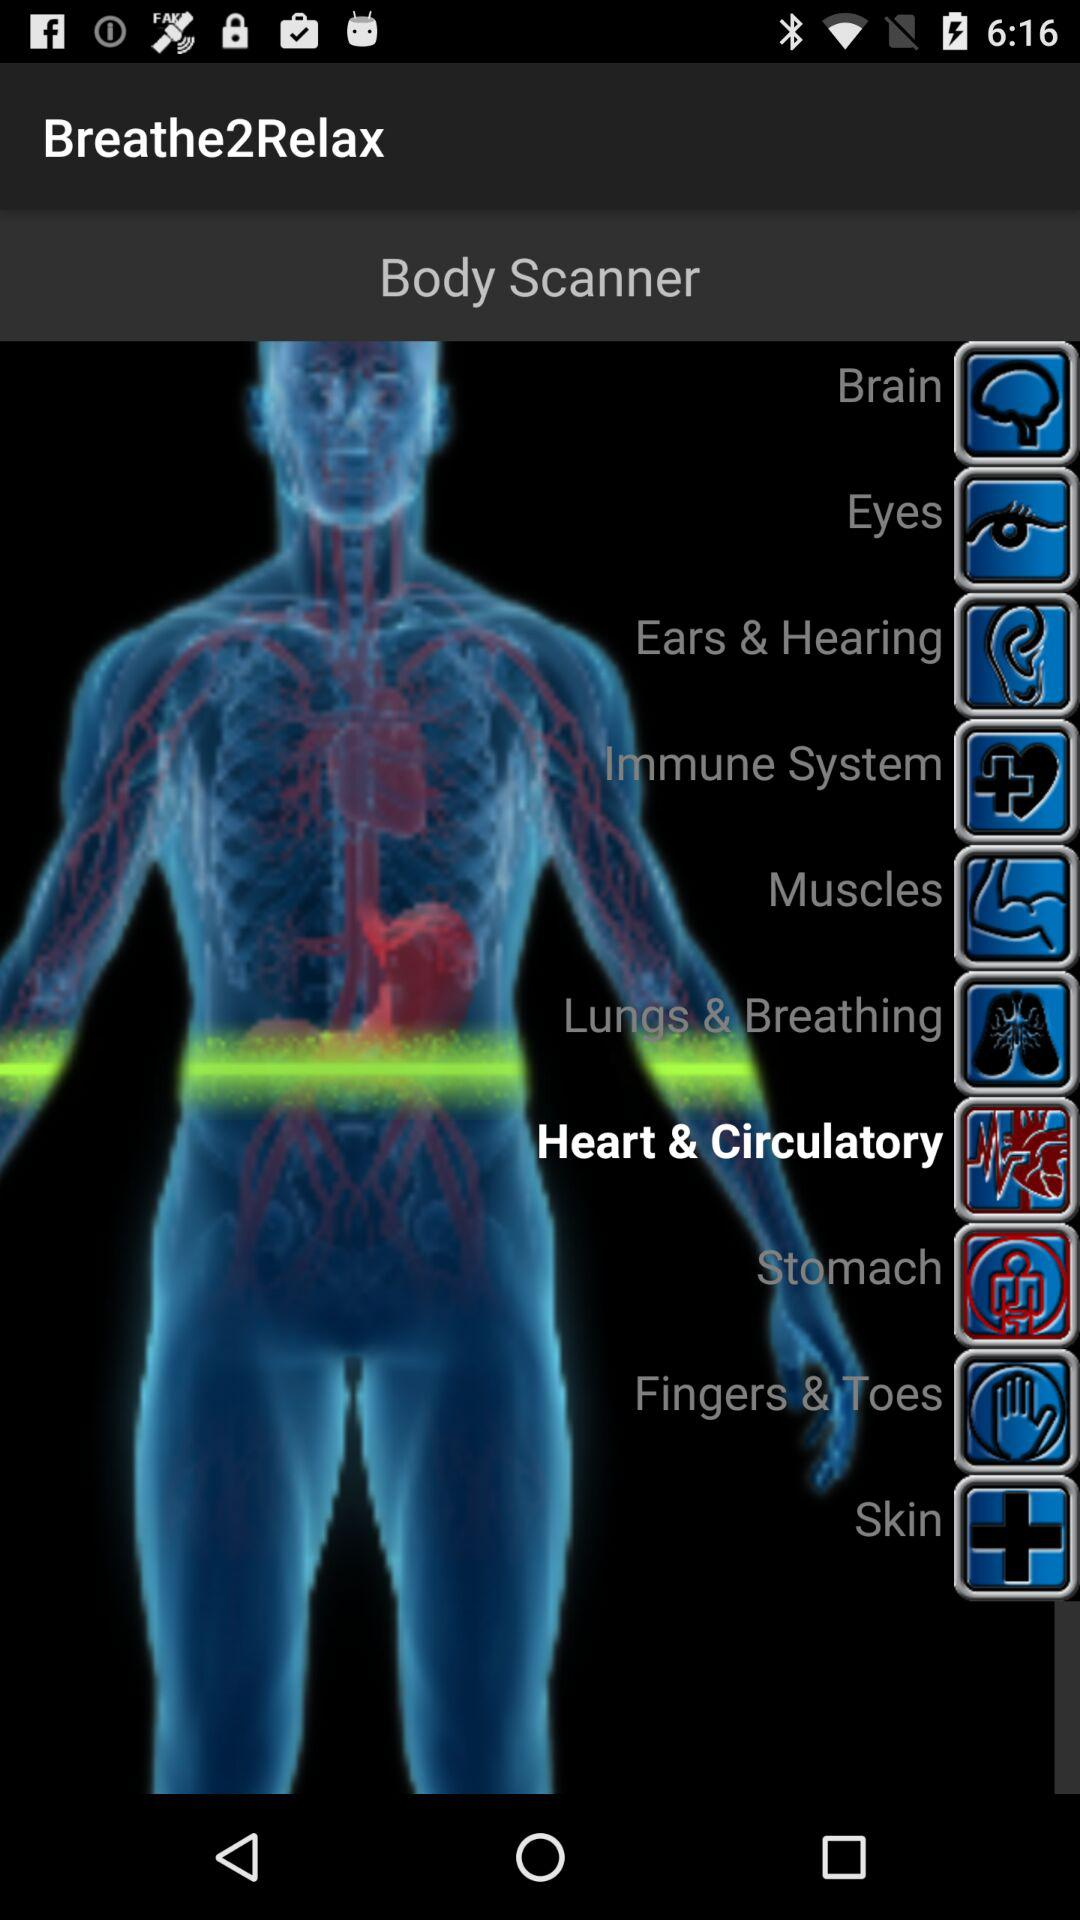What is the app name? The app name is "Breathe2Relax". 